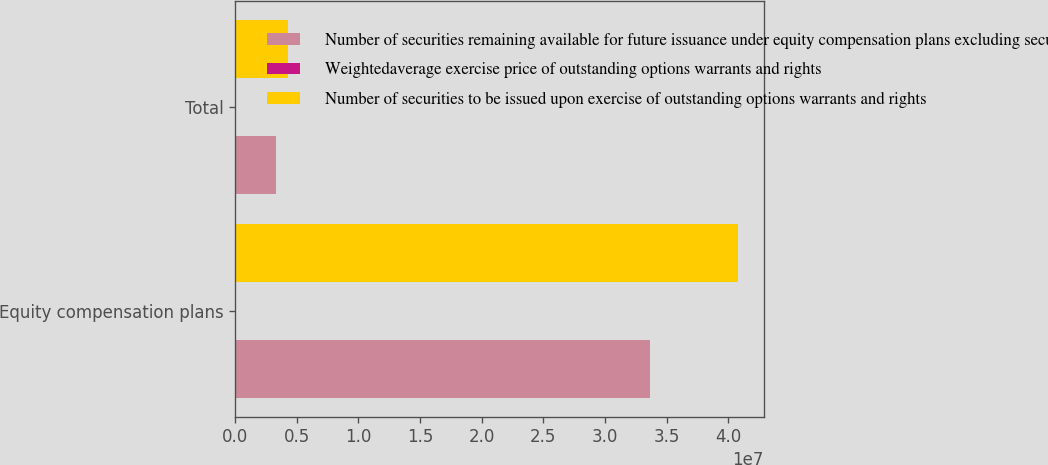Convert chart. <chart><loc_0><loc_0><loc_500><loc_500><stacked_bar_chart><ecel><fcel>Equity compensation plans<fcel>Total<nl><fcel>Number of securities remaining available for future issuance under equity compensation plans excluding securities reflected in column a<fcel>3.36391e+07<fcel>3.36391e+06<nl><fcel>Weightedaverage exercise price of outstanding options warrants and rights<fcel>37.49<fcel>37.49<nl><fcel>Number of securities to be issued upon exercise of outstanding options warrants and rights<fcel>4.08126e+07<fcel>4.25927e+06<nl></chart> 